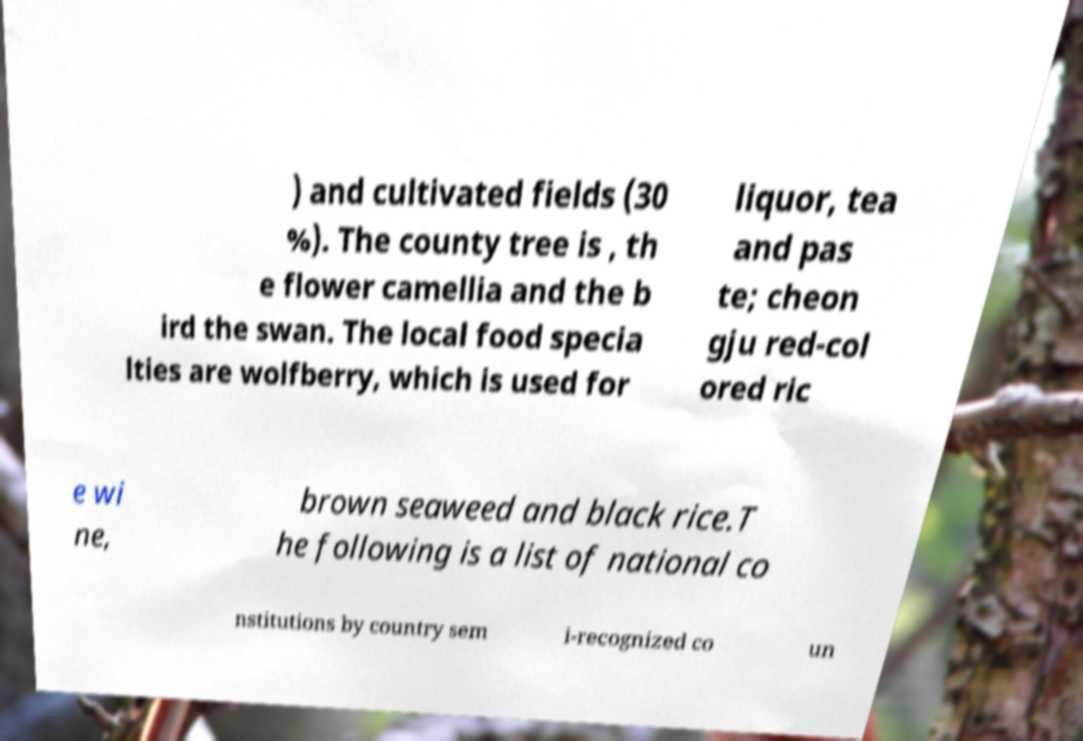What messages or text are displayed in this image? I need them in a readable, typed format. ) and cultivated fields (30 %). The county tree is , th e flower camellia and the b ird the swan. The local food specia lties are wolfberry, which is used for liquor, tea and pas te; cheon gju red-col ored ric e wi ne, brown seaweed and black rice.T he following is a list of national co nstitutions by country sem i-recognized co un 